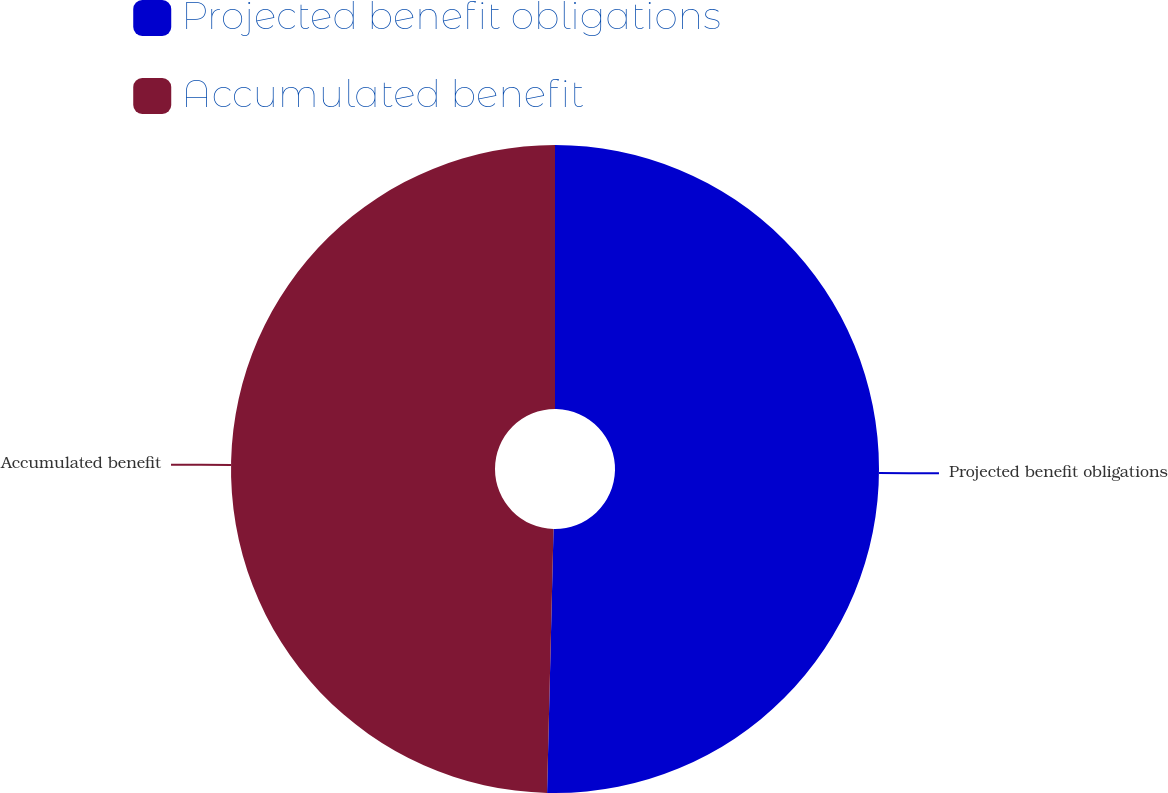Convert chart to OTSL. <chart><loc_0><loc_0><loc_500><loc_500><pie_chart><fcel>Projected benefit obligations<fcel>Accumulated benefit<nl><fcel>50.39%<fcel>49.61%<nl></chart> 